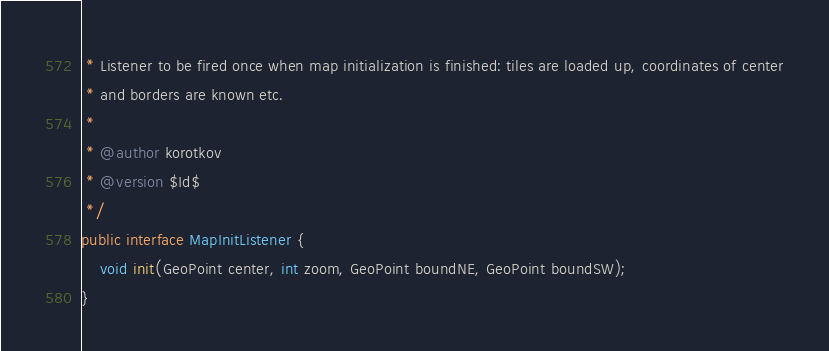<code> <loc_0><loc_0><loc_500><loc_500><_Java_> * Listener to be fired once when map initialization is finished: tiles are loaded up, coordinates of center
 * and borders are known etc.
 *
 * @author korotkov
 * @version $Id$
 */
public interface MapInitListener {
    void init(GeoPoint center, int zoom, GeoPoint boundNE, GeoPoint boundSW);
}
</code> 